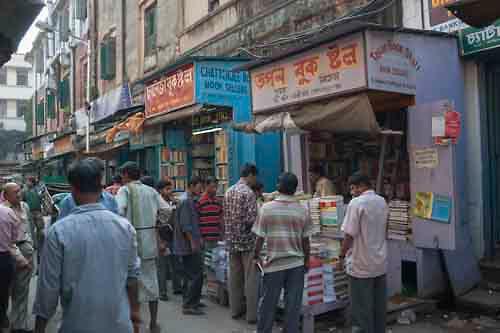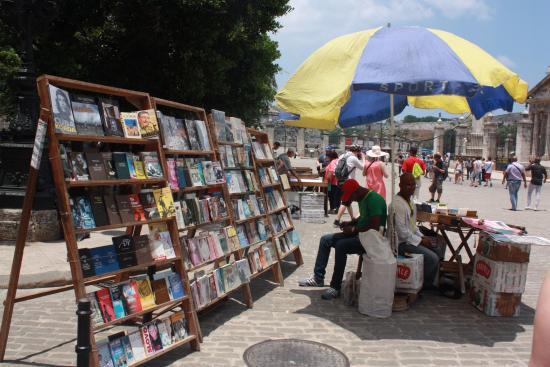The first image is the image on the left, the second image is the image on the right. Given the left and right images, does the statement "A vehicle is parked in the area near the sales in the image on the right." hold true? Answer yes or no. No. The first image is the image on the left, the second image is the image on the right. Analyze the images presented: Is the assertion "The sky is partially visible behind a book stall in the right image." valid? Answer yes or no. Yes. 